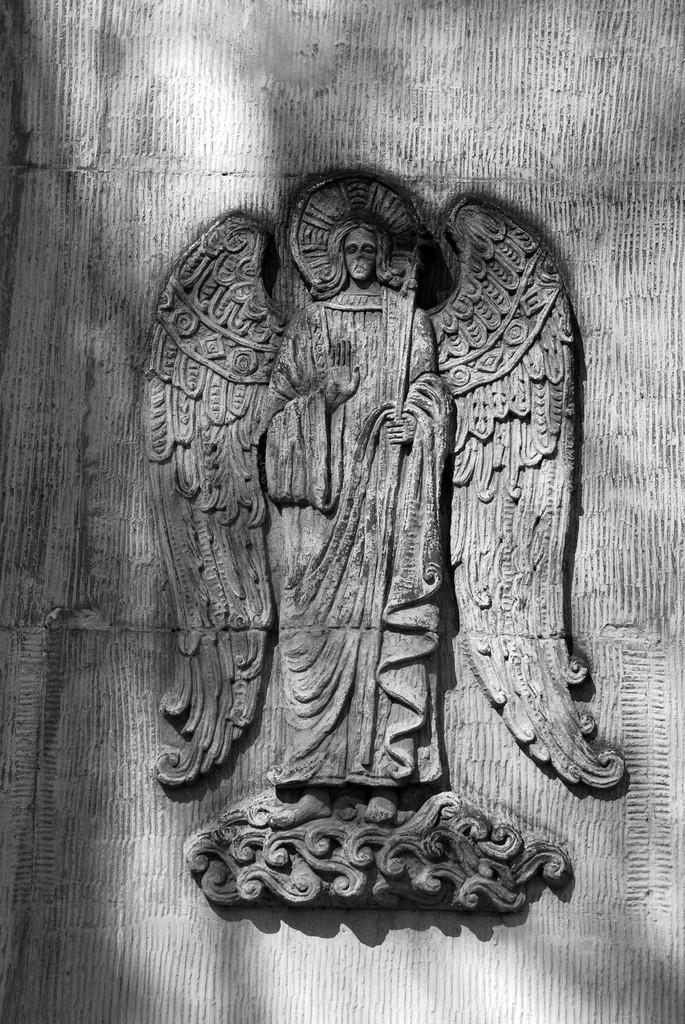What is depicted on the wall in the image? There is a carving of a person with wings on the wall in the image. How many ducks are present in the image? There are no ducks present in the image; it features a carving of a person with wings on the wall. What type of company is associated with the carving? The image? There is no indication of any company associated with the carving in the image. 